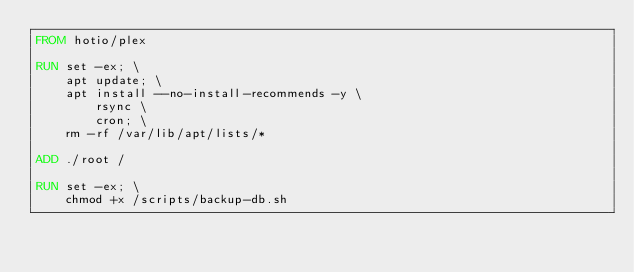Convert code to text. <code><loc_0><loc_0><loc_500><loc_500><_Dockerfile_>FROM hotio/plex

RUN set -ex; \
    apt update; \
    apt install --no-install-recommends -y \
        rsync \
        cron; \
    rm -rf /var/lib/apt/lists/*

ADD ./root /

RUN set -ex; \
    chmod +x /scripts/backup-db.sh
</code> 